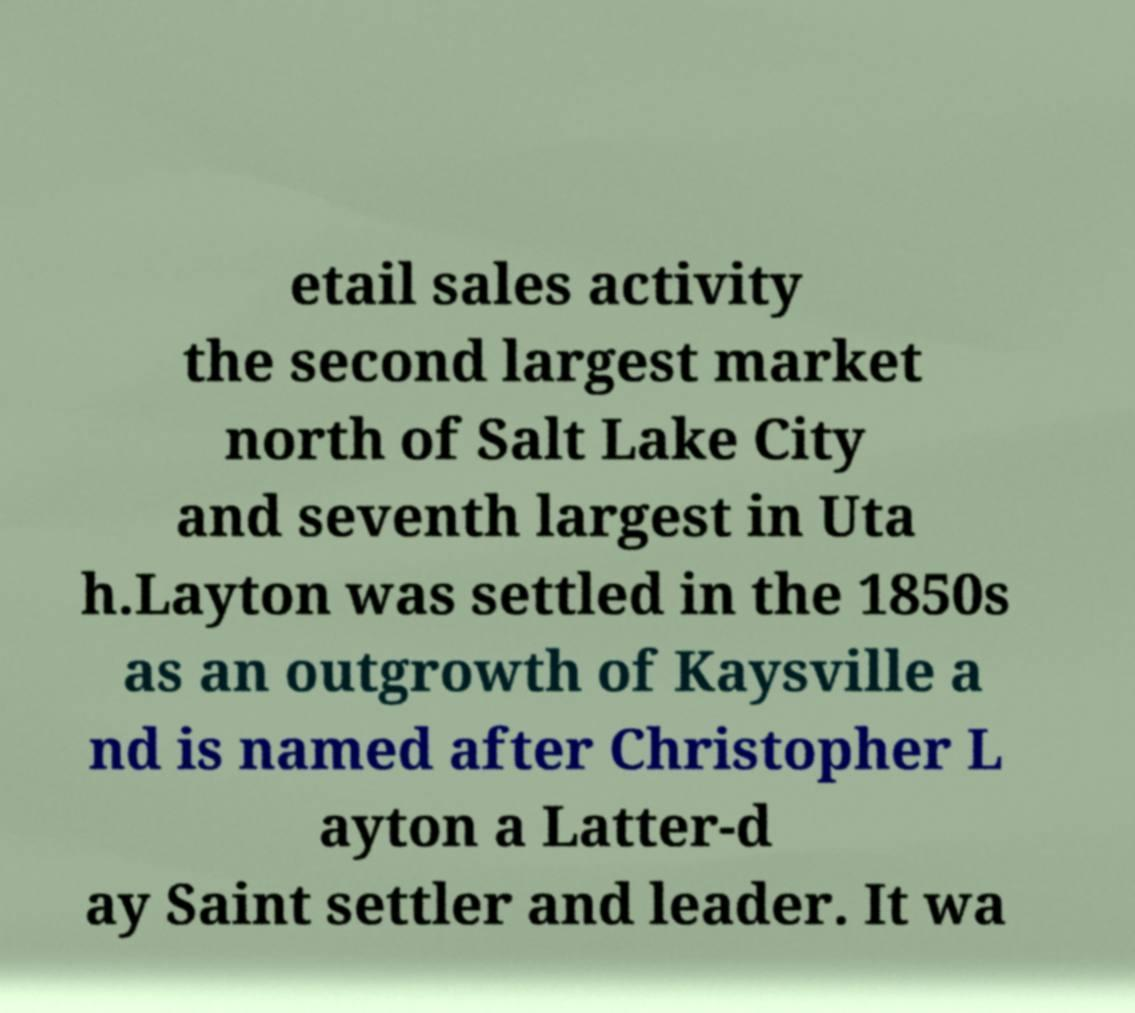I need the written content from this picture converted into text. Can you do that? etail sales activity the second largest market north of Salt Lake City and seventh largest in Uta h.Layton was settled in the 1850s as an outgrowth of Kaysville a nd is named after Christopher L ayton a Latter-d ay Saint settler and leader. It wa 